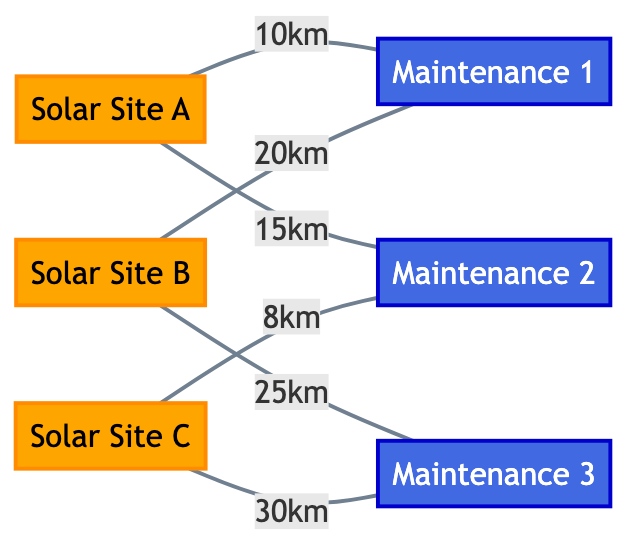What's the total number of nodes in the diagram? The diagram consists of three solar panel installation sites and three maintenance facilities, totaling six nodes.
Answer: 6 What is the distance between Site A and Maintenance Facility 2? The diagram indicates a connection between Site A and Maintenance Facility 2 with a distance of 15 kilometers.
Answer: 15 km Which maintenance facility is closest to Site C? The closest maintenance facility to Site C is Maintenance Facility 2, with a distance of 8 kilometers as shown in the diagram.
Answer: Maintenance Facility 2 How many edges connect to Maintenance Facility 1? Maintenance Facility 1 is connected to two sites: Site A and Site B, making a total of two edges leading to it.
Answer: 2 Which site has the farthest distance to a maintenance facility? Site B has the furthest connection to a maintenance facility, with a distance of 25 kilometers to Maintenance Facility 3, which is the longest distance in the diagram.
Answer: Site B Is there a direct connection from Site C to Maintenance Facility 1? There is no direct connection between Site C and Maintenance Facility 1 in the diagram; thus, no edge exists between these two nodes.
Answer: No What type of graph is represented in the diagram? The diagram showcases an undirected graph, where the connections (edges) between nodes (sites and facilities) do not have a directional flow, similar to a network.
Answer: Undirected Graph Which maintenance facility is connected to the most solar sites? Maintenance Facility 2 is connected to two solar sites: Site A and Site C, while others are connected to one site only. Hence, it has the most connections.
Answer: Maintenance Facility 2 